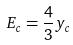<formula> <loc_0><loc_0><loc_500><loc_500>E _ { c } = \frac { 4 } { 3 } y _ { c }</formula> 